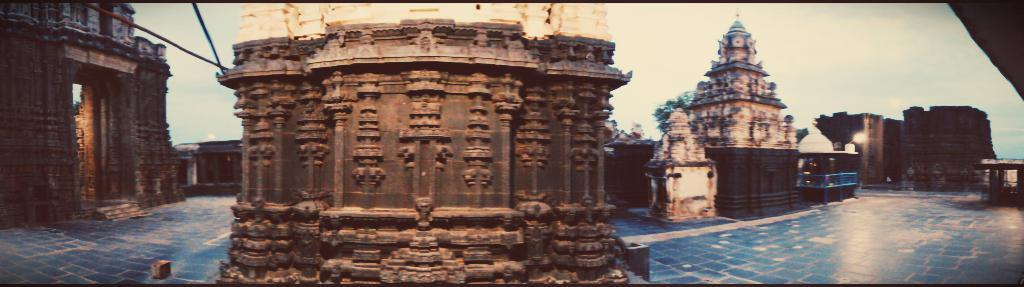How many different types of monuments can be seen in the image? There are four different types of monuments in the image. What type of creature can be seen interacting with the monuments in the image? There is no creature present in the image; it only features four different types of monuments. What type of basin is visible in the image? There is no basin present in the image; it only features four different types of monuments. 